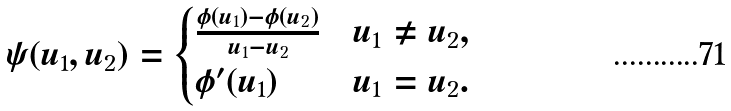<formula> <loc_0><loc_0><loc_500><loc_500>\psi ( u _ { 1 } , u _ { 2 } ) = \begin{cases} \frac { \phi ( u _ { 1 } ) - \phi ( u _ { 2 } ) } { u _ { 1 } - u _ { 2 } } & u _ { 1 } \neq u _ { 2 } , \\ \phi ^ { \prime } ( u _ { 1 } ) & u _ { 1 } = u _ { 2 } . \end{cases}</formula> 